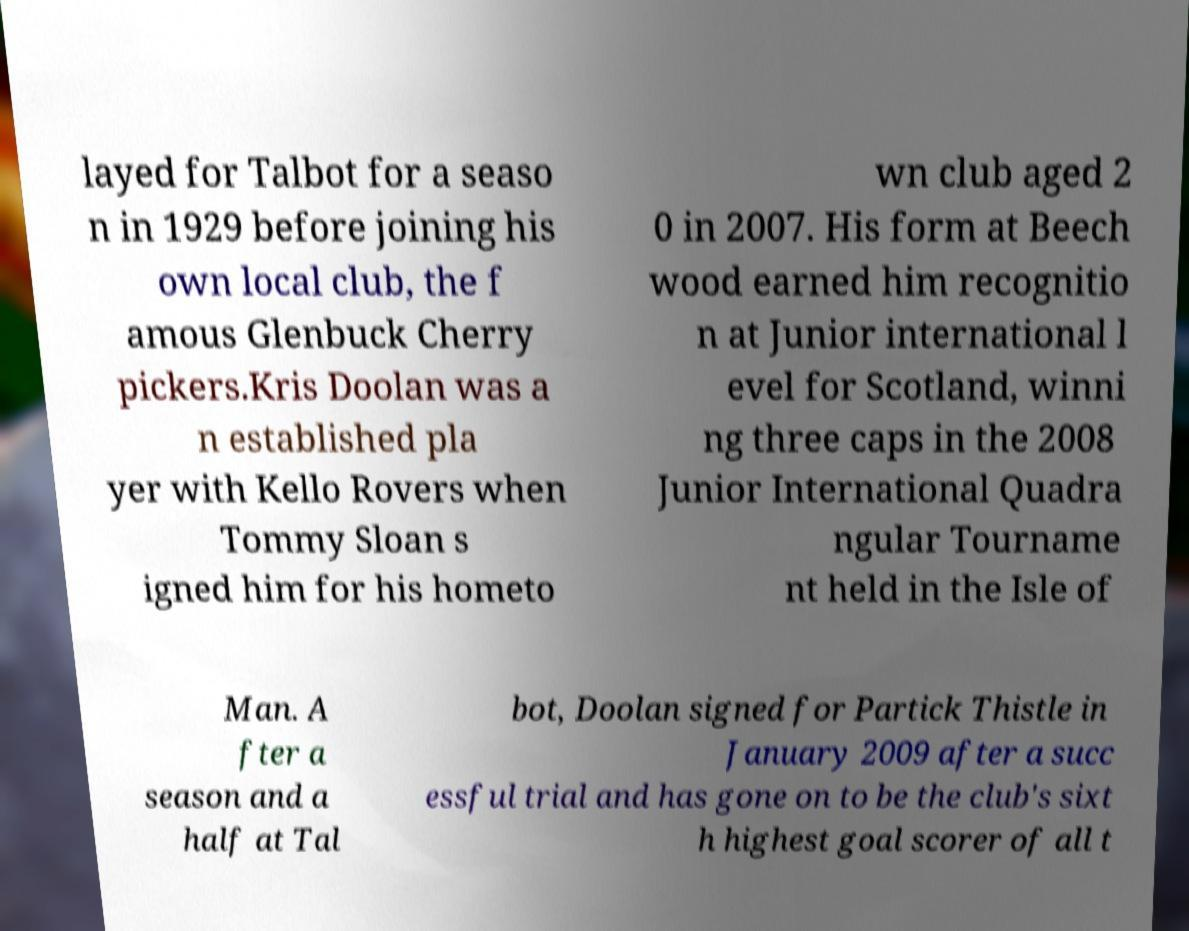Could you extract and type out the text from this image? layed for Talbot for a seaso n in 1929 before joining his own local club, the f amous Glenbuck Cherry pickers.Kris Doolan was a n established pla yer with Kello Rovers when Tommy Sloan s igned him for his hometo wn club aged 2 0 in 2007. His form at Beech wood earned him recognitio n at Junior international l evel for Scotland, winni ng three caps in the 2008 Junior International Quadra ngular Tourname nt held in the Isle of Man. A fter a season and a half at Tal bot, Doolan signed for Partick Thistle in January 2009 after a succ essful trial and has gone on to be the club's sixt h highest goal scorer of all t 